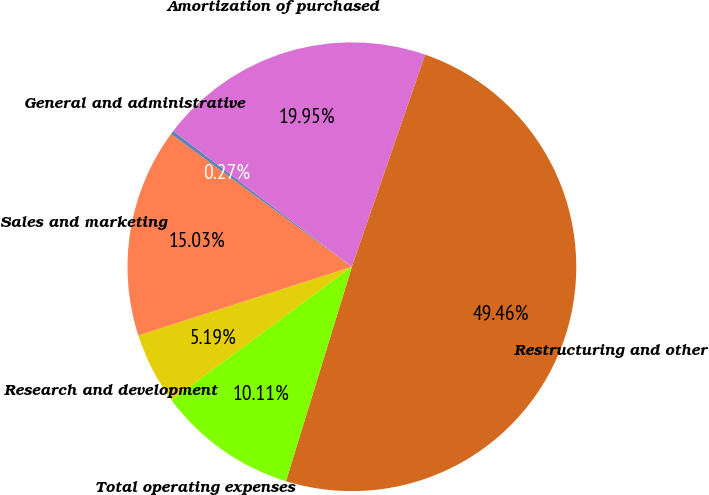Convert chart. <chart><loc_0><loc_0><loc_500><loc_500><pie_chart><fcel>Research and development<fcel>Sales and marketing<fcel>General and administrative<fcel>Amortization of purchased<fcel>Restructuring and other<fcel>Total operating expenses<nl><fcel>5.19%<fcel>15.03%<fcel>0.27%<fcel>19.95%<fcel>49.46%<fcel>10.11%<nl></chart> 